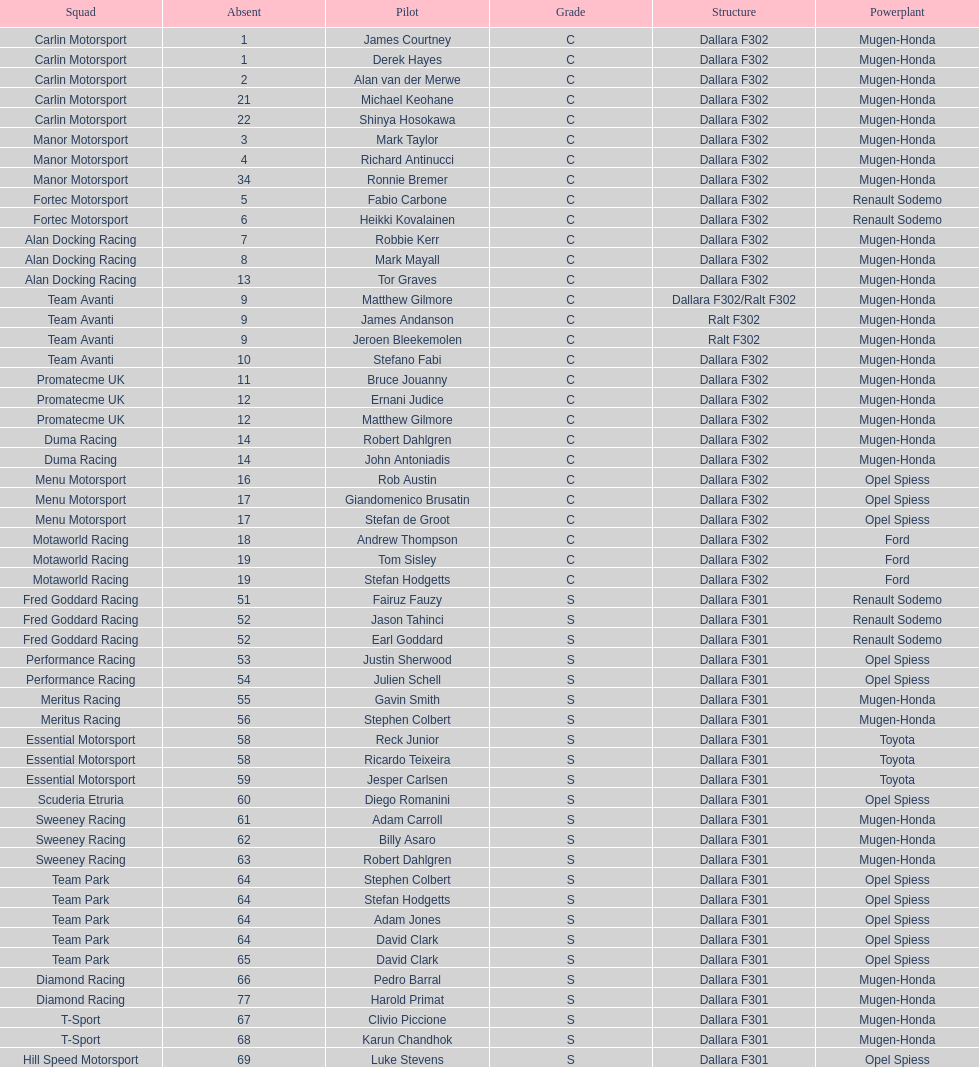Besides clivio piccione, who is the other driver on the t-sport team? Karun Chandhok. 